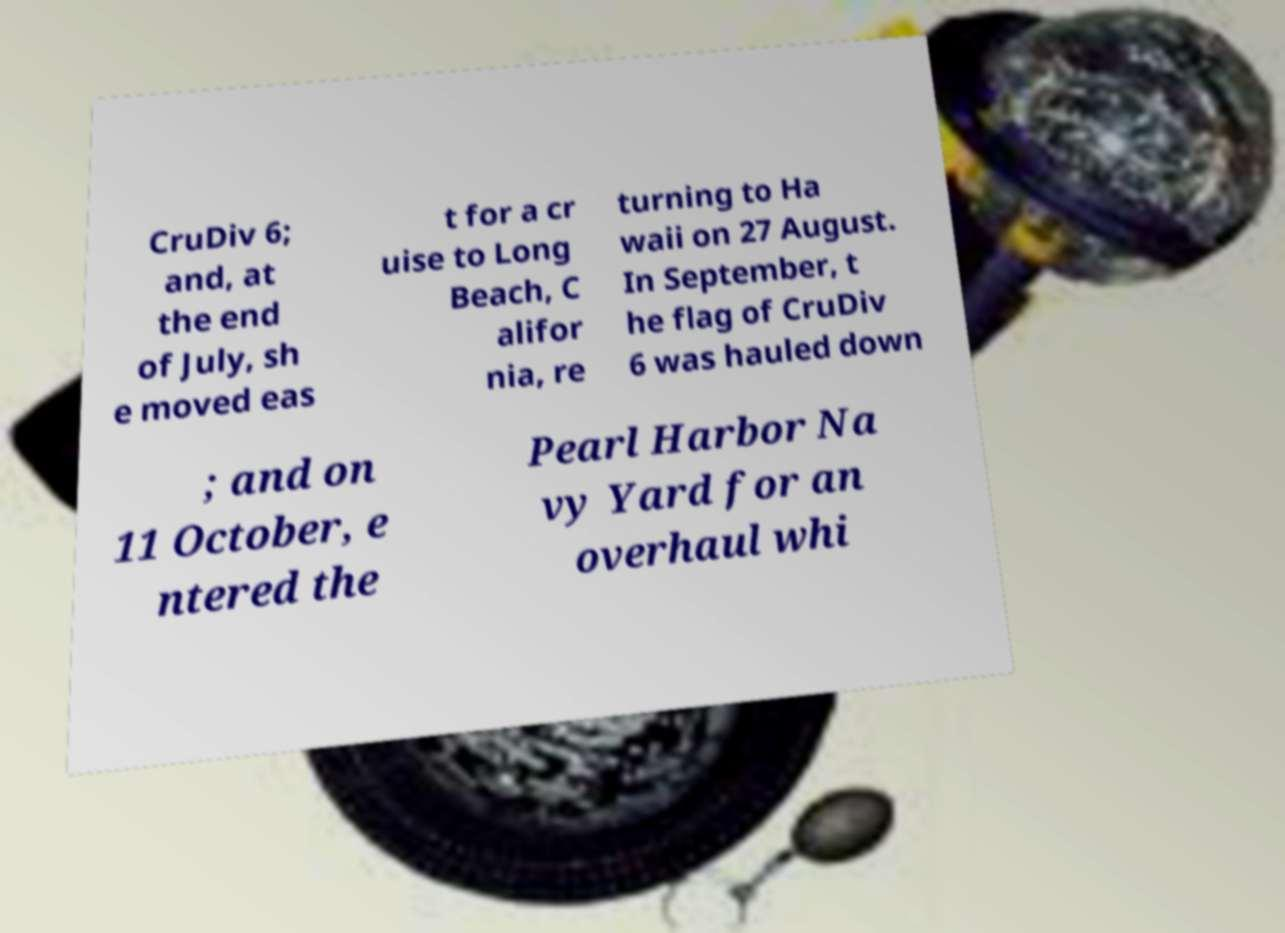Can you accurately transcribe the text from the provided image for me? CruDiv 6; and, at the end of July, sh e moved eas t for a cr uise to Long Beach, C alifor nia, re turning to Ha waii on 27 August. In September, t he flag of CruDiv 6 was hauled down ; and on 11 October, e ntered the Pearl Harbor Na vy Yard for an overhaul whi 